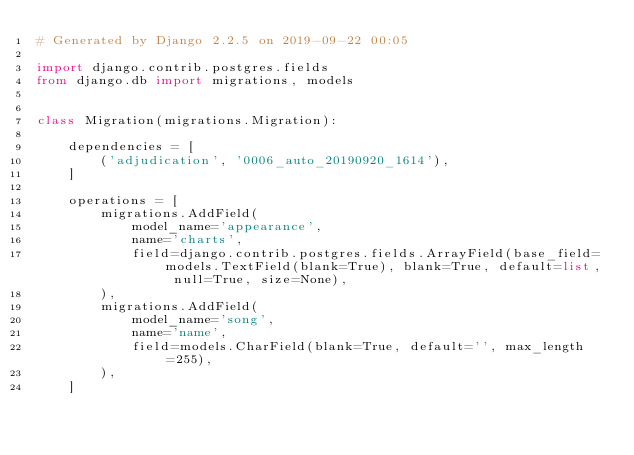Convert code to text. <code><loc_0><loc_0><loc_500><loc_500><_Python_># Generated by Django 2.2.5 on 2019-09-22 00:05

import django.contrib.postgres.fields
from django.db import migrations, models


class Migration(migrations.Migration):

    dependencies = [
        ('adjudication', '0006_auto_20190920_1614'),
    ]

    operations = [
        migrations.AddField(
            model_name='appearance',
            name='charts',
            field=django.contrib.postgres.fields.ArrayField(base_field=models.TextField(blank=True), blank=True, default=list, null=True, size=None),
        ),
        migrations.AddField(
            model_name='song',
            name='name',
            field=models.CharField(blank=True, default='', max_length=255),
        ),
    ]
</code> 